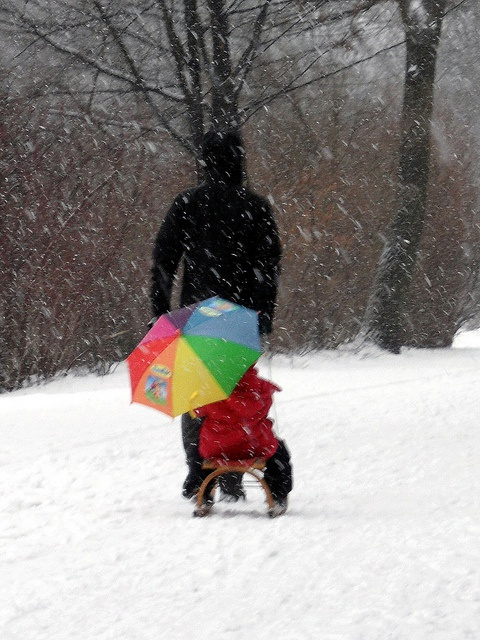Describe the objects in this image and their specific colors. I can see people in gray, black, and darkgray tones, umbrella in gray, tan, and green tones, and people in gray, maroon, and black tones in this image. 